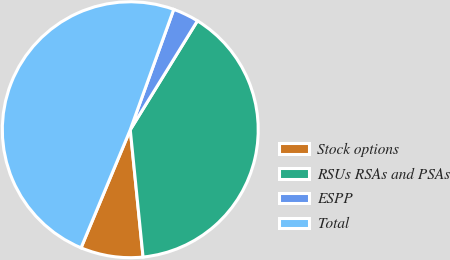Convert chart. <chart><loc_0><loc_0><loc_500><loc_500><pie_chart><fcel>Stock options<fcel>RSUs RSAs and PSAs<fcel>ESPP<fcel>Total<nl><fcel>7.88%<fcel>39.61%<fcel>3.28%<fcel>49.23%<nl></chart> 